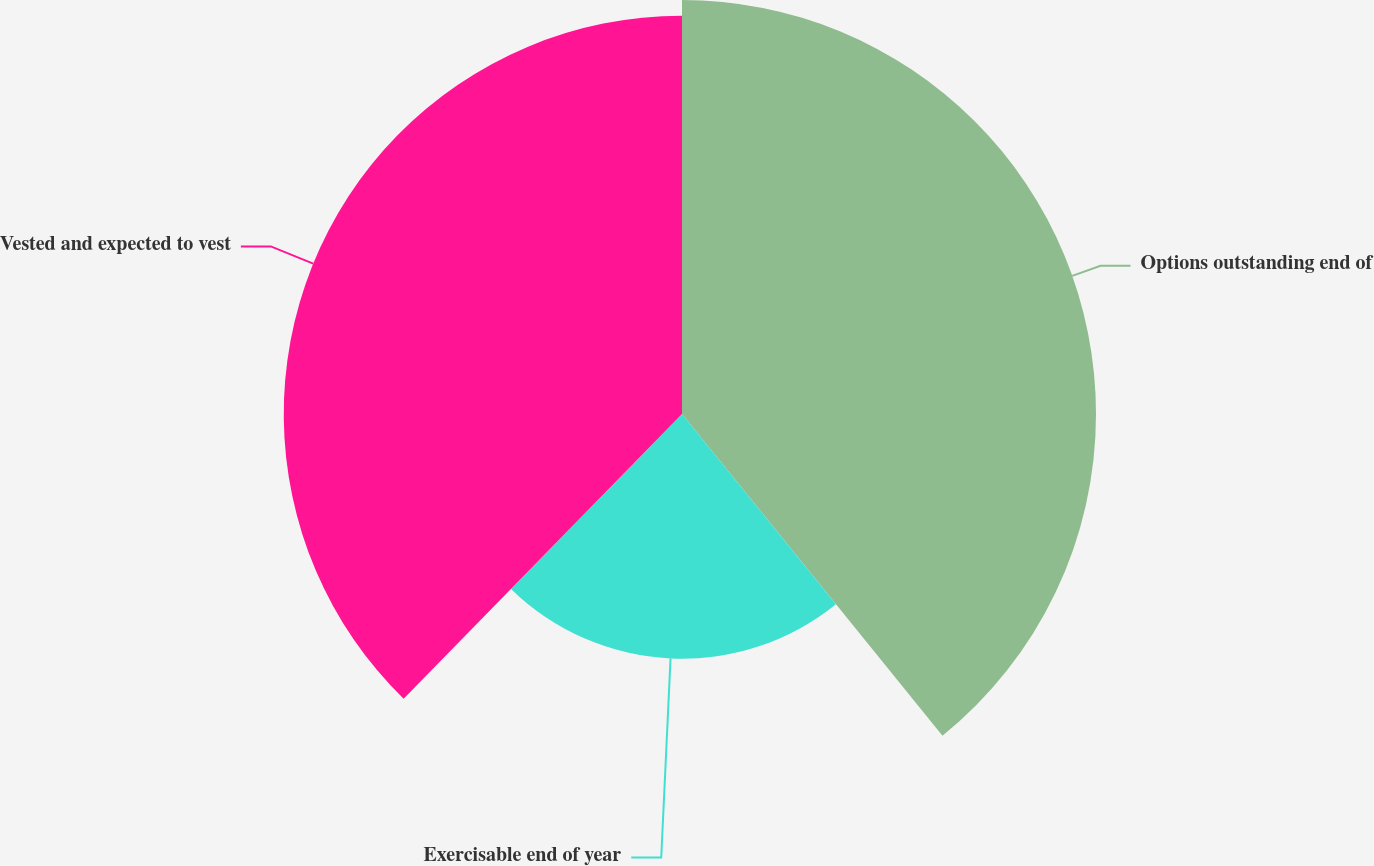Convert chart. <chart><loc_0><loc_0><loc_500><loc_500><pie_chart><fcel>Options outstanding end of<fcel>Exercisable end of year<fcel>Vested and expected to vest<nl><fcel>39.17%<fcel>23.15%<fcel>37.68%<nl></chart> 